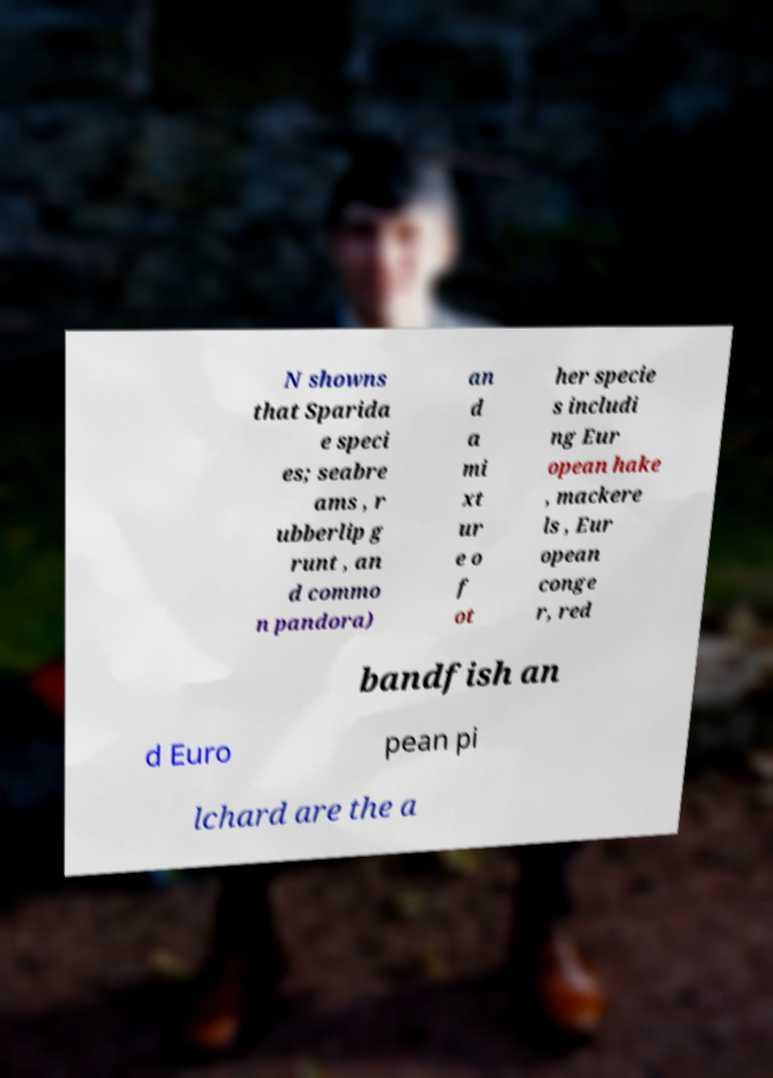I need the written content from this picture converted into text. Can you do that? N showns that Sparida e speci es; seabre ams , r ubberlip g runt , an d commo n pandora) an d a mi xt ur e o f ot her specie s includi ng Eur opean hake , mackere ls , Eur opean conge r, red bandfish an d Euro pean pi lchard are the a 